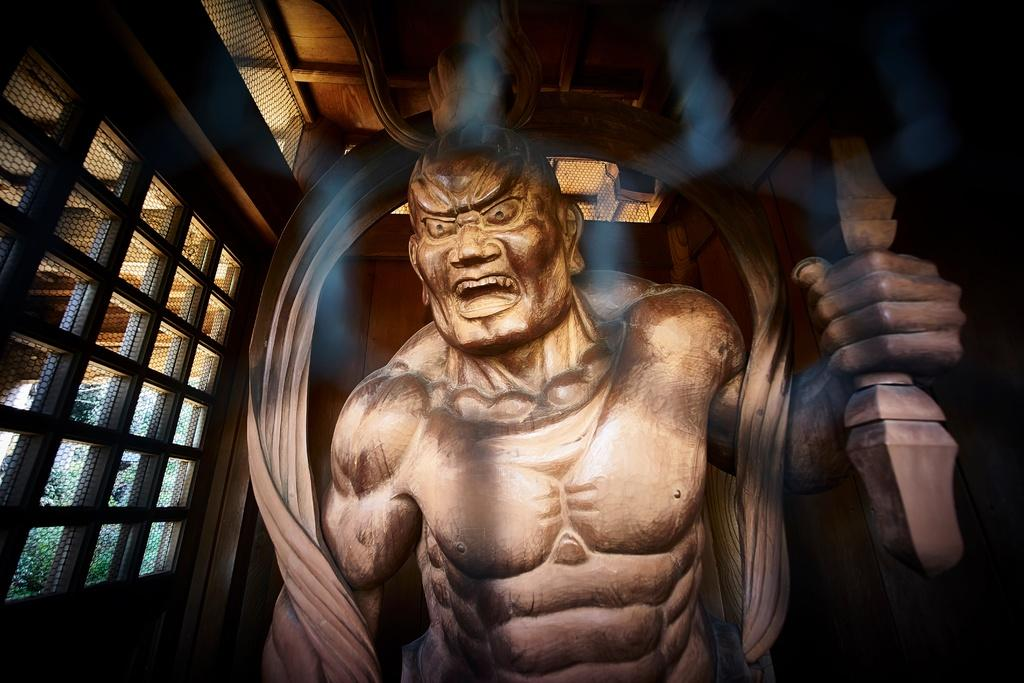What is the main subject in the foreground of the image? There is a person's sculpture in the foreground of the image. What can be seen in the background of the image? There are windows and walls visible in the background of the image. Can you describe the setting where the image might have been taken? The image may have been taken in a hall, given the presence of walls and windows. Can you see any signs of a kiss between the sculpture and the wall in the image? No, there is no indication of a kiss between the sculpture and the wall in the image. 